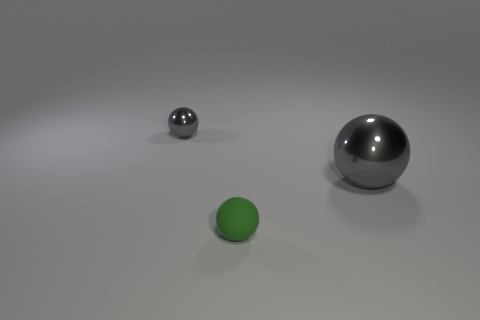Is there anything unique about the positioning of the spheres? The spheres are positioned at differing distances from one another, creating a sense of depth. The large ball is up front, centered, while the small metal sphere is further back, and a smaller green sphere to the front-left side, possibly suggesting an intentional arrangement for visual or artistic effect. 